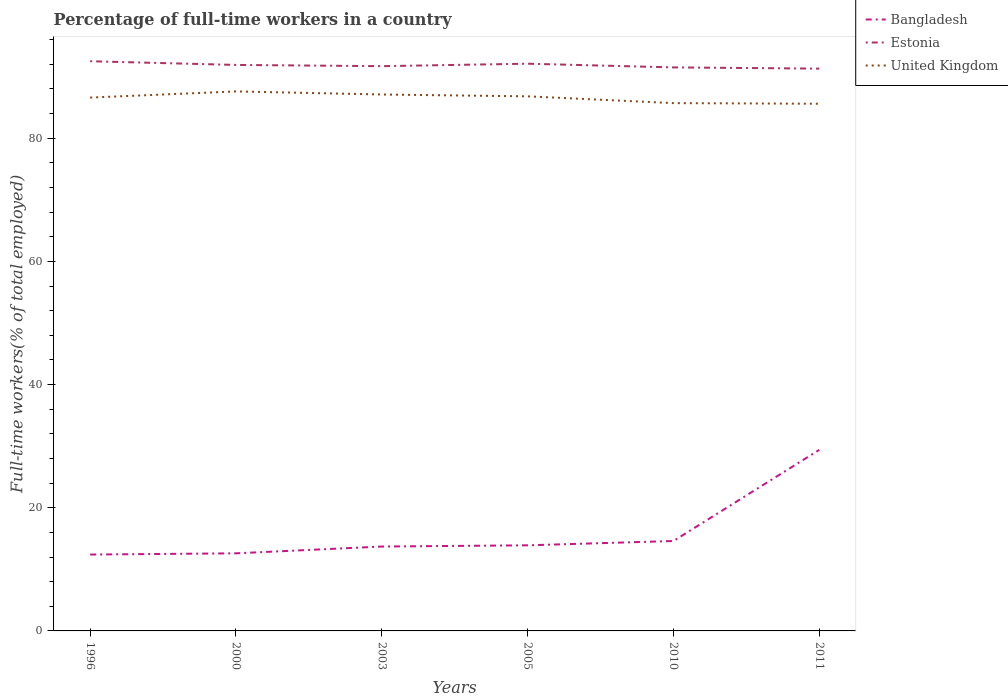How many different coloured lines are there?
Offer a very short reply. 3. Across all years, what is the maximum percentage of full-time workers in Bangladesh?
Your response must be concise. 12.4. In which year was the percentage of full-time workers in United Kingdom maximum?
Give a very brief answer. 2011. What is the total percentage of full-time workers in Bangladesh in the graph?
Make the answer very short. -14.8. Is the percentage of full-time workers in United Kingdom strictly greater than the percentage of full-time workers in Estonia over the years?
Your response must be concise. Yes. How many years are there in the graph?
Provide a short and direct response. 6. What is the difference between two consecutive major ticks on the Y-axis?
Provide a succinct answer. 20. Are the values on the major ticks of Y-axis written in scientific E-notation?
Give a very brief answer. No. Does the graph contain any zero values?
Keep it short and to the point. No. Does the graph contain grids?
Keep it short and to the point. No. What is the title of the graph?
Offer a terse response. Percentage of full-time workers in a country. Does "Norway" appear as one of the legend labels in the graph?
Your answer should be very brief. No. What is the label or title of the Y-axis?
Your answer should be compact. Full-time workers(% of total employed). What is the Full-time workers(% of total employed) of Bangladesh in 1996?
Ensure brevity in your answer.  12.4. What is the Full-time workers(% of total employed) of Estonia in 1996?
Make the answer very short. 92.5. What is the Full-time workers(% of total employed) of United Kingdom in 1996?
Your response must be concise. 86.6. What is the Full-time workers(% of total employed) in Bangladesh in 2000?
Provide a succinct answer. 12.6. What is the Full-time workers(% of total employed) of Estonia in 2000?
Provide a short and direct response. 91.9. What is the Full-time workers(% of total employed) in United Kingdom in 2000?
Offer a terse response. 87.6. What is the Full-time workers(% of total employed) of Bangladesh in 2003?
Make the answer very short. 13.7. What is the Full-time workers(% of total employed) in Estonia in 2003?
Provide a succinct answer. 91.7. What is the Full-time workers(% of total employed) of United Kingdom in 2003?
Provide a succinct answer. 87.1. What is the Full-time workers(% of total employed) in Bangladesh in 2005?
Keep it short and to the point. 13.9. What is the Full-time workers(% of total employed) in Estonia in 2005?
Offer a terse response. 92.1. What is the Full-time workers(% of total employed) of United Kingdom in 2005?
Offer a terse response. 86.8. What is the Full-time workers(% of total employed) in Bangladesh in 2010?
Offer a terse response. 14.6. What is the Full-time workers(% of total employed) in Estonia in 2010?
Offer a very short reply. 91.5. What is the Full-time workers(% of total employed) in United Kingdom in 2010?
Offer a terse response. 85.7. What is the Full-time workers(% of total employed) of Bangladesh in 2011?
Offer a terse response. 29.4. What is the Full-time workers(% of total employed) in Estonia in 2011?
Offer a very short reply. 91.3. What is the Full-time workers(% of total employed) in United Kingdom in 2011?
Ensure brevity in your answer.  85.6. Across all years, what is the maximum Full-time workers(% of total employed) of Bangladesh?
Make the answer very short. 29.4. Across all years, what is the maximum Full-time workers(% of total employed) of Estonia?
Provide a succinct answer. 92.5. Across all years, what is the maximum Full-time workers(% of total employed) of United Kingdom?
Your response must be concise. 87.6. Across all years, what is the minimum Full-time workers(% of total employed) of Bangladesh?
Provide a short and direct response. 12.4. Across all years, what is the minimum Full-time workers(% of total employed) in Estonia?
Offer a terse response. 91.3. Across all years, what is the minimum Full-time workers(% of total employed) in United Kingdom?
Provide a short and direct response. 85.6. What is the total Full-time workers(% of total employed) of Bangladesh in the graph?
Provide a succinct answer. 96.6. What is the total Full-time workers(% of total employed) of Estonia in the graph?
Your answer should be compact. 551. What is the total Full-time workers(% of total employed) in United Kingdom in the graph?
Give a very brief answer. 519.4. What is the difference between the Full-time workers(% of total employed) of Bangladesh in 1996 and that in 2000?
Provide a succinct answer. -0.2. What is the difference between the Full-time workers(% of total employed) in Estonia in 1996 and that in 2003?
Give a very brief answer. 0.8. What is the difference between the Full-time workers(% of total employed) of Estonia in 1996 and that in 2005?
Ensure brevity in your answer.  0.4. What is the difference between the Full-time workers(% of total employed) of Bangladesh in 1996 and that in 2010?
Keep it short and to the point. -2.2. What is the difference between the Full-time workers(% of total employed) of Estonia in 1996 and that in 2010?
Your response must be concise. 1. What is the difference between the Full-time workers(% of total employed) of United Kingdom in 1996 and that in 2010?
Provide a succinct answer. 0.9. What is the difference between the Full-time workers(% of total employed) in Bangladesh in 1996 and that in 2011?
Make the answer very short. -17. What is the difference between the Full-time workers(% of total employed) of Estonia in 1996 and that in 2011?
Provide a succinct answer. 1.2. What is the difference between the Full-time workers(% of total employed) in United Kingdom in 1996 and that in 2011?
Make the answer very short. 1. What is the difference between the Full-time workers(% of total employed) in United Kingdom in 2000 and that in 2003?
Your answer should be very brief. 0.5. What is the difference between the Full-time workers(% of total employed) in Bangladesh in 2000 and that in 2005?
Provide a short and direct response. -1.3. What is the difference between the Full-time workers(% of total employed) of Estonia in 2000 and that in 2005?
Ensure brevity in your answer.  -0.2. What is the difference between the Full-time workers(% of total employed) in United Kingdom in 2000 and that in 2005?
Keep it short and to the point. 0.8. What is the difference between the Full-time workers(% of total employed) of Estonia in 2000 and that in 2010?
Offer a very short reply. 0.4. What is the difference between the Full-time workers(% of total employed) of Bangladesh in 2000 and that in 2011?
Keep it short and to the point. -16.8. What is the difference between the Full-time workers(% of total employed) of Estonia in 2000 and that in 2011?
Offer a terse response. 0.6. What is the difference between the Full-time workers(% of total employed) of United Kingdom in 2003 and that in 2005?
Make the answer very short. 0.3. What is the difference between the Full-time workers(% of total employed) in United Kingdom in 2003 and that in 2010?
Provide a short and direct response. 1.4. What is the difference between the Full-time workers(% of total employed) in Bangladesh in 2003 and that in 2011?
Offer a very short reply. -15.7. What is the difference between the Full-time workers(% of total employed) in Estonia in 2003 and that in 2011?
Ensure brevity in your answer.  0.4. What is the difference between the Full-time workers(% of total employed) in United Kingdom in 2003 and that in 2011?
Your answer should be very brief. 1.5. What is the difference between the Full-time workers(% of total employed) of Bangladesh in 2005 and that in 2010?
Provide a short and direct response. -0.7. What is the difference between the Full-time workers(% of total employed) of Estonia in 2005 and that in 2010?
Make the answer very short. 0.6. What is the difference between the Full-time workers(% of total employed) of United Kingdom in 2005 and that in 2010?
Make the answer very short. 1.1. What is the difference between the Full-time workers(% of total employed) of Bangladesh in 2005 and that in 2011?
Your answer should be compact. -15.5. What is the difference between the Full-time workers(% of total employed) of Estonia in 2005 and that in 2011?
Ensure brevity in your answer.  0.8. What is the difference between the Full-time workers(% of total employed) in United Kingdom in 2005 and that in 2011?
Offer a terse response. 1.2. What is the difference between the Full-time workers(% of total employed) of Bangladesh in 2010 and that in 2011?
Your answer should be very brief. -14.8. What is the difference between the Full-time workers(% of total employed) in United Kingdom in 2010 and that in 2011?
Offer a very short reply. 0.1. What is the difference between the Full-time workers(% of total employed) in Bangladesh in 1996 and the Full-time workers(% of total employed) in Estonia in 2000?
Keep it short and to the point. -79.5. What is the difference between the Full-time workers(% of total employed) of Bangladesh in 1996 and the Full-time workers(% of total employed) of United Kingdom in 2000?
Offer a very short reply. -75.2. What is the difference between the Full-time workers(% of total employed) in Bangladesh in 1996 and the Full-time workers(% of total employed) in Estonia in 2003?
Your answer should be very brief. -79.3. What is the difference between the Full-time workers(% of total employed) of Bangladesh in 1996 and the Full-time workers(% of total employed) of United Kingdom in 2003?
Your answer should be very brief. -74.7. What is the difference between the Full-time workers(% of total employed) of Estonia in 1996 and the Full-time workers(% of total employed) of United Kingdom in 2003?
Keep it short and to the point. 5.4. What is the difference between the Full-time workers(% of total employed) of Bangladesh in 1996 and the Full-time workers(% of total employed) of Estonia in 2005?
Provide a succinct answer. -79.7. What is the difference between the Full-time workers(% of total employed) in Bangladesh in 1996 and the Full-time workers(% of total employed) in United Kingdom in 2005?
Provide a short and direct response. -74.4. What is the difference between the Full-time workers(% of total employed) of Estonia in 1996 and the Full-time workers(% of total employed) of United Kingdom in 2005?
Provide a short and direct response. 5.7. What is the difference between the Full-time workers(% of total employed) in Bangladesh in 1996 and the Full-time workers(% of total employed) in Estonia in 2010?
Provide a short and direct response. -79.1. What is the difference between the Full-time workers(% of total employed) in Bangladesh in 1996 and the Full-time workers(% of total employed) in United Kingdom in 2010?
Give a very brief answer. -73.3. What is the difference between the Full-time workers(% of total employed) of Bangladesh in 1996 and the Full-time workers(% of total employed) of Estonia in 2011?
Your response must be concise. -78.9. What is the difference between the Full-time workers(% of total employed) of Bangladesh in 1996 and the Full-time workers(% of total employed) of United Kingdom in 2011?
Make the answer very short. -73.2. What is the difference between the Full-time workers(% of total employed) in Bangladesh in 2000 and the Full-time workers(% of total employed) in Estonia in 2003?
Keep it short and to the point. -79.1. What is the difference between the Full-time workers(% of total employed) in Bangladesh in 2000 and the Full-time workers(% of total employed) in United Kingdom in 2003?
Offer a terse response. -74.5. What is the difference between the Full-time workers(% of total employed) of Estonia in 2000 and the Full-time workers(% of total employed) of United Kingdom in 2003?
Give a very brief answer. 4.8. What is the difference between the Full-time workers(% of total employed) in Bangladesh in 2000 and the Full-time workers(% of total employed) in Estonia in 2005?
Make the answer very short. -79.5. What is the difference between the Full-time workers(% of total employed) in Bangladesh in 2000 and the Full-time workers(% of total employed) in United Kingdom in 2005?
Keep it short and to the point. -74.2. What is the difference between the Full-time workers(% of total employed) of Bangladesh in 2000 and the Full-time workers(% of total employed) of Estonia in 2010?
Ensure brevity in your answer.  -78.9. What is the difference between the Full-time workers(% of total employed) of Bangladesh in 2000 and the Full-time workers(% of total employed) of United Kingdom in 2010?
Keep it short and to the point. -73.1. What is the difference between the Full-time workers(% of total employed) of Bangladesh in 2000 and the Full-time workers(% of total employed) of Estonia in 2011?
Your answer should be very brief. -78.7. What is the difference between the Full-time workers(% of total employed) of Bangladesh in 2000 and the Full-time workers(% of total employed) of United Kingdom in 2011?
Keep it short and to the point. -73. What is the difference between the Full-time workers(% of total employed) in Bangladesh in 2003 and the Full-time workers(% of total employed) in Estonia in 2005?
Provide a succinct answer. -78.4. What is the difference between the Full-time workers(% of total employed) in Bangladesh in 2003 and the Full-time workers(% of total employed) in United Kingdom in 2005?
Provide a succinct answer. -73.1. What is the difference between the Full-time workers(% of total employed) of Estonia in 2003 and the Full-time workers(% of total employed) of United Kingdom in 2005?
Provide a short and direct response. 4.9. What is the difference between the Full-time workers(% of total employed) in Bangladesh in 2003 and the Full-time workers(% of total employed) in Estonia in 2010?
Provide a short and direct response. -77.8. What is the difference between the Full-time workers(% of total employed) in Bangladesh in 2003 and the Full-time workers(% of total employed) in United Kingdom in 2010?
Give a very brief answer. -72. What is the difference between the Full-time workers(% of total employed) in Estonia in 2003 and the Full-time workers(% of total employed) in United Kingdom in 2010?
Your answer should be very brief. 6. What is the difference between the Full-time workers(% of total employed) of Bangladesh in 2003 and the Full-time workers(% of total employed) of Estonia in 2011?
Make the answer very short. -77.6. What is the difference between the Full-time workers(% of total employed) of Bangladesh in 2003 and the Full-time workers(% of total employed) of United Kingdom in 2011?
Make the answer very short. -71.9. What is the difference between the Full-time workers(% of total employed) of Estonia in 2003 and the Full-time workers(% of total employed) of United Kingdom in 2011?
Provide a short and direct response. 6.1. What is the difference between the Full-time workers(% of total employed) of Bangladesh in 2005 and the Full-time workers(% of total employed) of Estonia in 2010?
Your answer should be very brief. -77.6. What is the difference between the Full-time workers(% of total employed) of Bangladesh in 2005 and the Full-time workers(% of total employed) of United Kingdom in 2010?
Your response must be concise. -71.8. What is the difference between the Full-time workers(% of total employed) in Bangladesh in 2005 and the Full-time workers(% of total employed) in Estonia in 2011?
Your response must be concise. -77.4. What is the difference between the Full-time workers(% of total employed) in Bangladesh in 2005 and the Full-time workers(% of total employed) in United Kingdom in 2011?
Keep it short and to the point. -71.7. What is the difference between the Full-time workers(% of total employed) of Bangladesh in 2010 and the Full-time workers(% of total employed) of Estonia in 2011?
Make the answer very short. -76.7. What is the difference between the Full-time workers(% of total employed) of Bangladesh in 2010 and the Full-time workers(% of total employed) of United Kingdom in 2011?
Give a very brief answer. -71. What is the difference between the Full-time workers(% of total employed) of Estonia in 2010 and the Full-time workers(% of total employed) of United Kingdom in 2011?
Make the answer very short. 5.9. What is the average Full-time workers(% of total employed) in Estonia per year?
Offer a terse response. 91.83. What is the average Full-time workers(% of total employed) in United Kingdom per year?
Provide a succinct answer. 86.57. In the year 1996, what is the difference between the Full-time workers(% of total employed) of Bangladesh and Full-time workers(% of total employed) of Estonia?
Your response must be concise. -80.1. In the year 1996, what is the difference between the Full-time workers(% of total employed) in Bangladesh and Full-time workers(% of total employed) in United Kingdom?
Give a very brief answer. -74.2. In the year 1996, what is the difference between the Full-time workers(% of total employed) in Estonia and Full-time workers(% of total employed) in United Kingdom?
Provide a short and direct response. 5.9. In the year 2000, what is the difference between the Full-time workers(% of total employed) of Bangladesh and Full-time workers(% of total employed) of Estonia?
Your answer should be very brief. -79.3. In the year 2000, what is the difference between the Full-time workers(% of total employed) of Bangladesh and Full-time workers(% of total employed) of United Kingdom?
Make the answer very short. -75. In the year 2000, what is the difference between the Full-time workers(% of total employed) in Estonia and Full-time workers(% of total employed) in United Kingdom?
Offer a terse response. 4.3. In the year 2003, what is the difference between the Full-time workers(% of total employed) in Bangladesh and Full-time workers(% of total employed) in Estonia?
Make the answer very short. -78. In the year 2003, what is the difference between the Full-time workers(% of total employed) of Bangladesh and Full-time workers(% of total employed) of United Kingdom?
Ensure brevity in your answer.  -73.4. In the year 2003, what is the difference between the Full-time workers(% of total employed) in Estonia and Full-time workers(% of total employed) in United Kingdom?
Offer a terse response. 4.6. In the year 2005, what is the difference between the Full-time workers(% of total employed) in Bangladesh and Full-time workers(% of total employed) in Estonia?
Your answer should be compact. -78.2. In the year 2005, what is the difference between the Full-time workers(% of total employed) of Bangladesh and Full-time workers(% of total employed) of United Kingdom?
Offer a very short reply. -72.9. In the year 2010, what is the difference between the Full-time workers(% of total employed) in Bangladesh and Full-time workers(% of total employed) in Estonia?
Give a very brief answer. -76.9. In the year 2010, what is the difference between the Full-time workers(% of total employed) in Bangladesh and Full-time workers(% of total employed) in United Kingdom?
Make the answer very short. -71.1. In the year 2011, what is the difference between the Full-time workers(% of total employed) in Bangladesh and Full-time workers(% of total employed) in Estonia?
Your answer should be very brief. -61.9. In the year 2011, what is the difference between the Full-time workers(% of total employed) of Bangladesh and Full-time workers(% of total employed) of United Kingdom?
Make the answer very short. -56.2. In the year 2011, what is the difference between the Full-time workers(% of total employed) of Estonia and Full-time workers(% of total employed) of United Kingdom?
Your answer should be compact. 5.7. What is the ratio of the Full-time workers(% of total employed) of Bangladesh in 1996 to that in 2000?
Your response must be concise. 0.98. What is the ratio of the Full-time workers(% of total employed) in Estonia in 1996 to that in 2000?
Ensure brevity in your answer.  1.01. What is the ratio of the Full-time workers(% of total employed) of United Kingdom in 1996 to that in 2000?
Make the answer very short. 0.99. What is the ratio of the Full-time workers(% of total employed) in Bangladesh in 1996 to that in 2003?
Keep it short and to the point. 0.91. What is the ratio of the Full-time workers(% of total employed) of Estonia in 1996 to that in 2003?
Provide a succinct answer. 1.01. What is the ratio of the Full-time workers(% of total employed) in United Kingdom in 1996 to that in 2003?
Keep it short and to the point. 0.99. What is the ratio of the Full-time workers(% of total employed) in Bangladesh in 1996 to that in 2005?
Make the answer very short. 0.89. What is the ratio of the Full-time workers(% of total employed) of Bangladesh in 1996 to that in 2010?
Provide a short and direct response. 0.85. What is the ratio of the Full-time workers(% of total employed) in Estonia in 1996 to that in 2010?
Offer a terse response. 1.01. What is the ratio of the Full-time workers(% of total employed) of United Kingdom in 1996 to that in 2010?
Keep it short and to the point. 1.01. What is the ratio of the Full-time workers(% of total employed) of Bangladesh in 1996 to that in 2011?
Ensure brevity in your answer.  0.42. What is the ratio of the Full-time workers(% of total employed) in Estonia in 1996 to that in 2011?
Your response must be concise. 1.01. What is the ratio of the Full-time workers(% of total employed) in United Kingdom in 1996 to that in 2011?
Offer a very short reply. 1.01. What is the ratio of the Full-time workers(% of total employed) in Bangladesh in 2000 to that in 2003?
Ensure brevity in your answer.  0.92. What is the ratio of the Full-time workers(% of total employed) of United Kingdom in 2000 to that in 2003?
Your response must be concise. 1.01. What is the ratio of the Full-time workers(% of total employed) of Bangladesh in 2000 to that in 2005?
Offer a terse response. 0.91. What is the ratio of the Full-time workers(% of total employed) of Estonia in 2000 to that in 2005?
Your response must be concise. 1. What is the ratio of the Full-time workers(% of total employed) in United Kingdom in 2000 to that in 2005?
Your answer should be very brief. 1.01. What is the ratio of the Full-time workers(% of total employed) in Bangladesh in 2000 to that in 2010?
Make the answer very short. 0.86. What is the ratio of the Full-time workers(% of total employed) in Estonia in 2000 to that in 2010?
Provide a short and direct response. 1. What is the ratio of the Full-time workers(% of total employed) in United Kingdom in 2000 to that in 2010?
Provide a succinct answer. 1.02. What is the ratio of the Full-time workers(% of total employed) of Bangladesh in 2000 to that in 2011?
Your answer should be very brief. 0.43. What is the ratio of the Full-time workers(% of total employed) of Estonia in 2000 to that in 2011?
Your response must be concise. 1.01. What is the ratio of the Full-time workers(% of total employed) in United Kingdom in 2000 to that in 2011?
Provide a short and direct response. 1.02. What is the ratio of the Full-time workers(% of total employed) in Bangladesh in 2003 to that in 2005?
Ensure brevity in your answer.  0.99. What is the ratio of the Full-time workers(% of total employed) in Estonia in 2003 to that in 2005?
Provide a short and direct response. 1. What is the ratio of the Full-time workers(% of total employed) of United Kingdom in 2003 to that in 2005?
Keep it short and to the point. 1. What is the ratio of the Full-time workers(% of total employed) in Bangladesh in 2003 to that in 2010?
Your answer should be compact. 0.94. What is the ratio of the Full-time workers(% of total employed) of Estonia in 2003 to that in 2010?
Offer a terse response. 1. What is the ratio of the Full-time workers(% of total employed) in United Kingdom in 2003 to that in 2010?
Your response must be concise. 1.02. What is the ratio of the Full-time workers(% of total employed) in Bangladesh in 2003 to that in 2011?
Give a very brief answer. 0.47. What is the ratio of the Full-time workers(% of total employed) of United Kingdom in 2003 to that in 2011?
Give a very brief answer. 1.02. What is the ratio of the Full-time workers(% of total employed) in Bangladesh in 2005 to that in 2010?
Your answer should be very brief. 0.95. What is the ratio of the Full-time workers(% of total employed) of Estonia in 2005 to that in 2010?
Keep it short and to the point. 1.01. What is the ratio of the Full-time workers(% of total employed) of United Kingdom in 2005 to that in 2010?
Keep it short and to the point. 1.01. What is the ratio of the Full-time workers(% of total employed) in Bangladesh in 2005 to that in 2011?
Your answer should be compact. 0.47. What is the ratio of the Full-time workers(% of total employed) of Estonia in 2005 to that in 2011?
Your answer should be compact. 1.01. What is the ratio of the Full-time workers(% of total employed) of Bangladesh in 2010 to that in 2011?
Your answer should be compact. 0.5. What is the ratio of the Full-time workers(% of total employed) in Estonia in 2010 to that in 2011?
Ensure brevity in your answer.  1. What is the ratio of the Full-time workers(% of total employed) in United Kingdom in 2010 to that in 2011?
Provide a succinct answer. 1. What is the difference between the highest and the second highest Full-time workers(% of total employed) of Bangladesh?
Give a very brief answer. 14.8. 